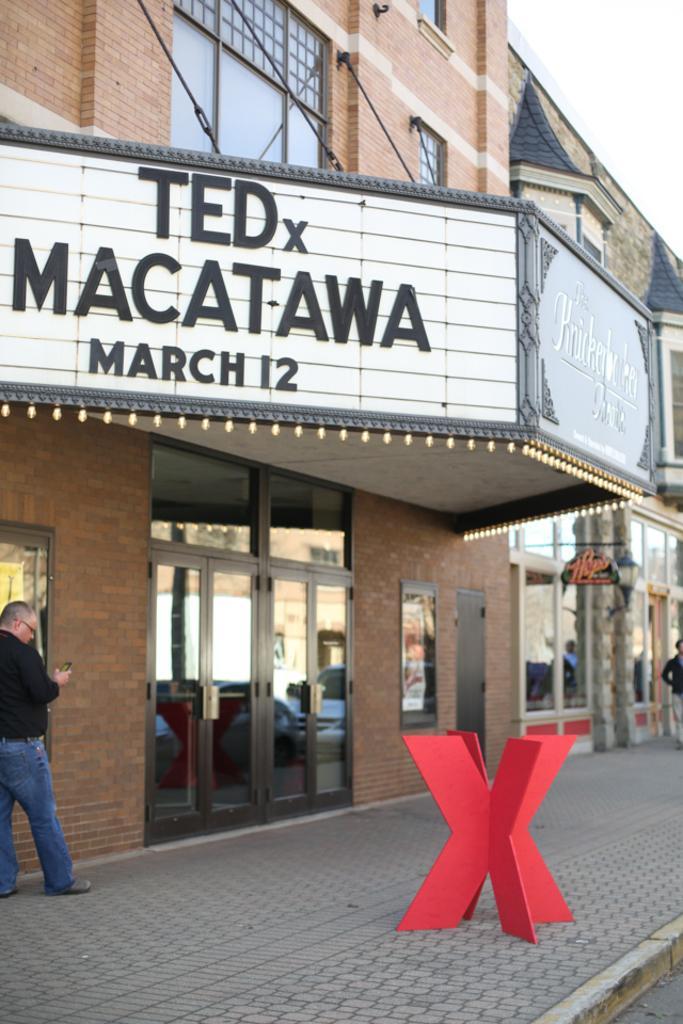How would you summarize this image in a sentence or two? In this image, we can see a building with glass windows and doors. Here we can see a hoarding, lights. At the bottom, there is a platform, some object here. Two people are standing on the platform. On the glass, we can see few vehicles are reflecting. Here there is a banner. 